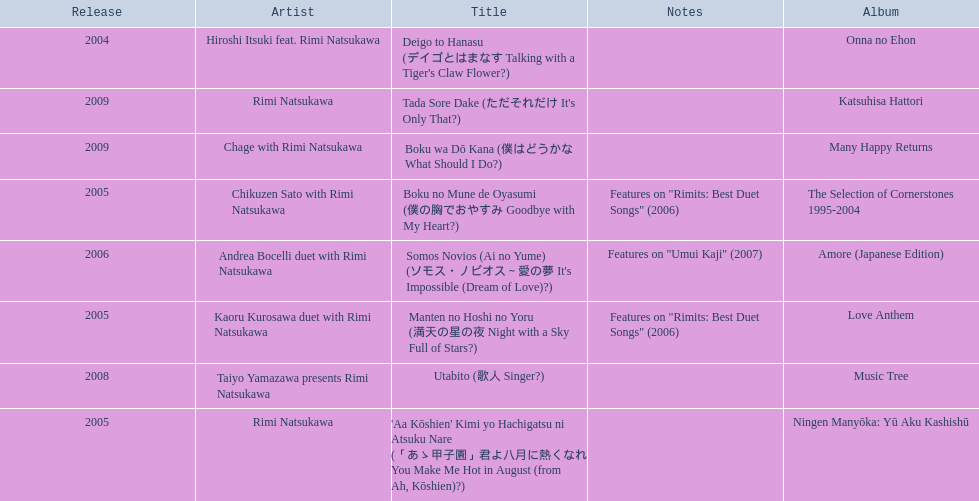What year was onna no ehon released? 2004. What year was music tree released? 2008. Which of the two was not released in 2004? Music Tree. 